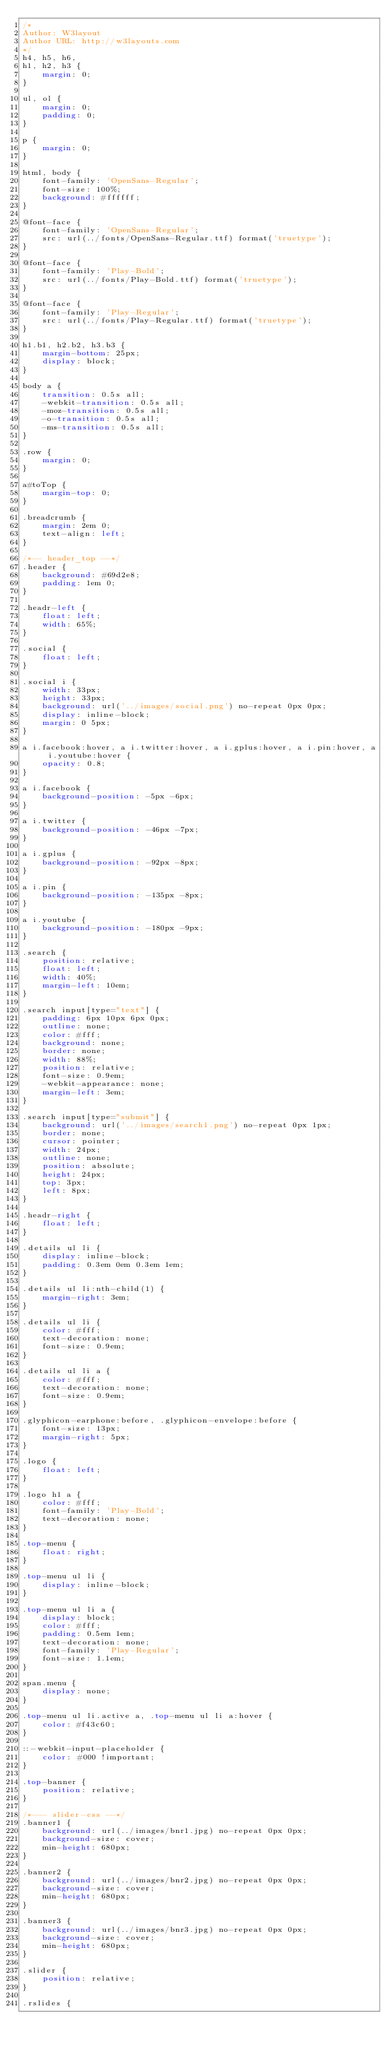Convert code to text. <code><loc_0><loc_0><loc_500><loc_500><_CSS_>/*
Author: W3layout
Author URL: http://w3layouts.com
*/
h4, h5, h6,
h1, h2, h3 {
    margin: 0;
}

ul, ol {
    margin: 0;
    padding: 0;
}

p {
    margin: 0;
}

html, body {
    font-family: 'OpenSans-Regular';
    font-size: 100%;
    background: #ffffff;
}

@font-face {
    font-family: 'OpenSans-Regular';
    src: url(../fonts/OpenSans-Regular.ttf) format('truetype');
}

@font-face {
    font-family: 'Play-Bold';
    src: url(../fonts/Play-Bold.ttf) format('truetype');
}

@font-face {
    font-family: 'Play-Regular';
    src: url(../fonts/Play-Regular.ttf) format('truetype');
}

h1.b1, h2.b2, h3.b3 {
    margin-bottom: 25px;
    display: block;
}

body a {
    transition: 0.5s all;
    -webkit-transition: 0.5s all;
    -moz-transition: 0.5s all;
    -o-transition: 0.5s all;
    -ms-transition: 0.5s all;
}

.row {
    margin: 0;
}

a#toTop {
    margin-top: 0;
}

.breadcrumb {
    margin: 2em 0;
    text-align: left;
}

/*-- header_top --*/
.header {
    background: #69d2e8;
    padding: 1em 0;
}

.headr-left {
    float: left;
    width: 65%;
}

.social {
    float: left;
}

.social i {
    width: 33px;
    height: 33px;
    background: url('../images/social.png') no-repeat 0px 0px;
    display: inline-block;
    margin: 0 5px;
}

a i.facebook:hover, a i.twitter:hover, a i.gplus:hover, a i.pin:hover, a i.youtube:hover {
    opacity: 0.8;
}

a i.facebook {
    background-position: -5px -6px;
}

a i.twitter {
    background-position: -46px -7px;
}

a i.gplus {
    background-position: -92px -8px;
}

a i.pin {
    background-position: -135px -8px;
}

a i.youtube {
    background-position: -180px -9px;
}

.search {
    position: relative;
    float: left;
    width: 40%;
    margin-left: 10em;
}

.search input[type="text"] {
    padding: 6px 10px 6px 0px;
    outline: none;
    color: #fff;
    background: none;
    border: none;
    width: 88%;
    position: relative;
    font-size: 0.9em;
    -webkit-appearance: none;
    margin-left: 3em;
}

.search input[type="submit"] {
    background: url('../images/search1.png') no-repeat 0px 1px;
    border: none;
    cursor: pointer;
    width: 24px;
    outline: none;
    position: absolute;
    height: 24px;
    top: 3px;
    left: 8px;
}

.headr-right {
    float: left;
}

.details ul li {
    display: inline-block;
    padding: 0.3em 0em 0.3em 1em;
}

.details ul li:nth-child(1) {
    margin-right: 3em;
}

.details ul li {
    color: #fff;
    text-decoration: none;
    font-size: 0.9em;
}

.details ul li a {
    color: #fff;
    text-decoration: none;
    font-size: 0.9em;
}

.glyphicon-earphone:before, .glyphicon-envelope:before {
    font-size: 13px;
    margin-right: 5px;
}

.logo {
    float: left;
}

.logo h1 a {
    color: #fff;
    font-family: 'Play-Bold';
    text-decoration: none;
}

.top-menu {
    float: right;
}

.top-menu ul li {
    display: inline-block;
}

.top-menu ul li a {
    display: block;
    color: #fff;
    padding: 0.5em 1em;
    text-decoration: none;
    font-family: 'Play-Regular';
    font-size: 1.1em;
}

span.menu {
    display: none;
}

.top-menu ul li.active a, .top-menu ul li a:hover {
    color: #f43c60;
}

::-webkit-input-placeholder {
    color: #000 !important;
}

.top-banner {
    position: relative;
}

/*--- slider-css --*/
.banner1 {
    background: url(../images/bnr1.jpg) no-repeat 0px 0px;
    background-size: cover;
    min-height: 680px;
}

.banner2 {
    background: url(../images/bnr2.jpg) no-repeat 0px 0px;
    background-size: cover;
    min-height: 680px;
}

.banner3 {
    background: url(../images/bnr3.jpg) no-repeat 0px 0px;
    background-size: cover;
    min-height: 680px;
}

.slider {
    position: relative;
}

.rslides {</code> 